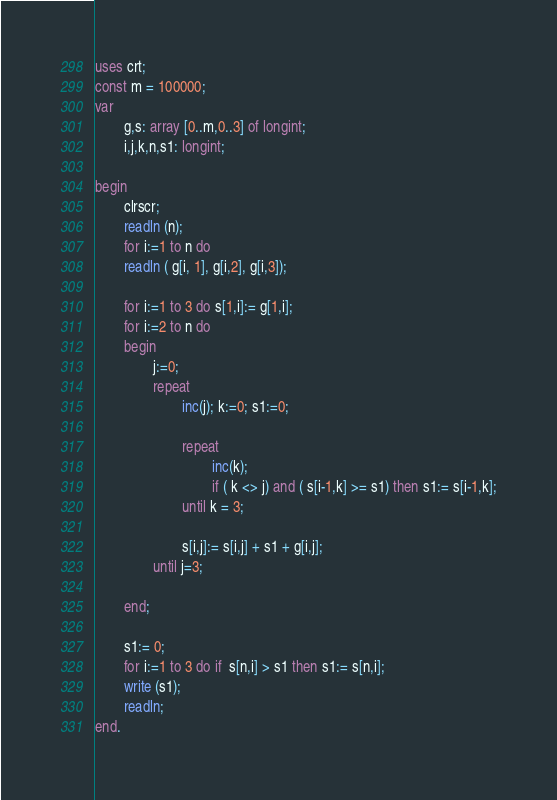<code> <loc_0><loc_0><loc_500><loc_500><_Pascal_>uses crt;
const m = 100000;
var
        g,s: array [0..m,0..3] of longint;
        i,j,k,n,s1: longint;

begin
        clrscr;
        readln (n);
        for i:=1 to n do
        readln ( g[i, 1], g[i,2], g[i,3]);

        for i:=1 to 3 do s[1,i]:= g[1,i];
        for i:=2 to n do
        begin
                j:=0;
                repeat
                        inc(j); k:=0; s1:=0;

                        repeat
                                inc(k);
                                if ( k <> j) and ( s[i-1,k] >= s1) then s1:= s[i-1,k];
                        until k = 3;

                        s[i,j]:= s[i,j] + s1 + g[i,j];
                until j=3;

        end;

        s1:= 0;
        for i:=1 to 3 do if  s[n,i] > s1 then s1:= s[n,i];
        write (s1);
        readln;
end.</code> 